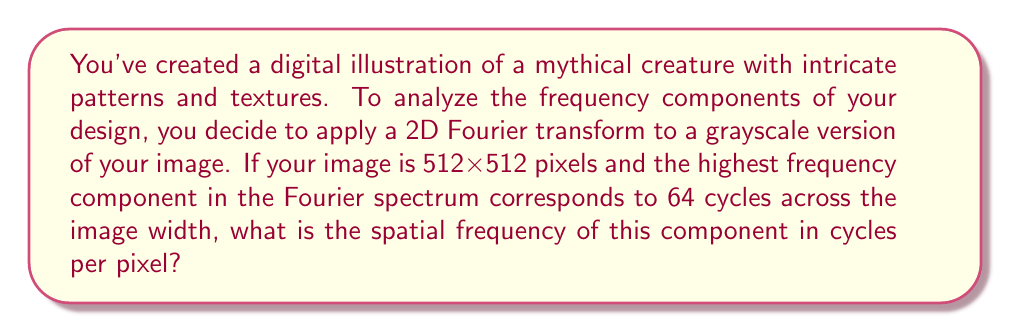Solve this math problem. To solve this problem, we need to understand the relationship between the image size, the number of cycles, and the spatial frequency in the context of the Fourier transform.

1. Image size: 512x512 pixels

2. Highest frequency component: 64 cycles across the image width

The spatial frequency is typically measured in cycles per pixel. To find this, we need to divide the number of cycles by the number of pixels:

$$ \text{Spatial Frequency} = \frac{\text{Number of Cycles}}{\text{Number of Pixels}} $$

In this case:
$$ \text{Spatial Frequency} = \frac{64 \text{ cycles}}{512 \text{ pixels}} $$

Simplifying:
$$ \text{Spatial Frequency} = \frac{1}{8} \text{ cycles/pixel} $$

It's worth noting that in the context of the Fourier transform, this highest frequency component would be located at the edge of the frequency spectrum. The Nyquist frequency, which is the highest frequency that can be represented in a discrete signal, would be 0.5 cycles/pixel (corresponding to a pattern that alternates every other pixel).

This analysis can help you understand the level of detail in your mythical creature design. Lower spatial frequencies correspond to larger, broader features, while higher spatial frequencies represent finer details and textures in your illustration.
Answer: $\frac{1}{8}$ cycles/pixel 